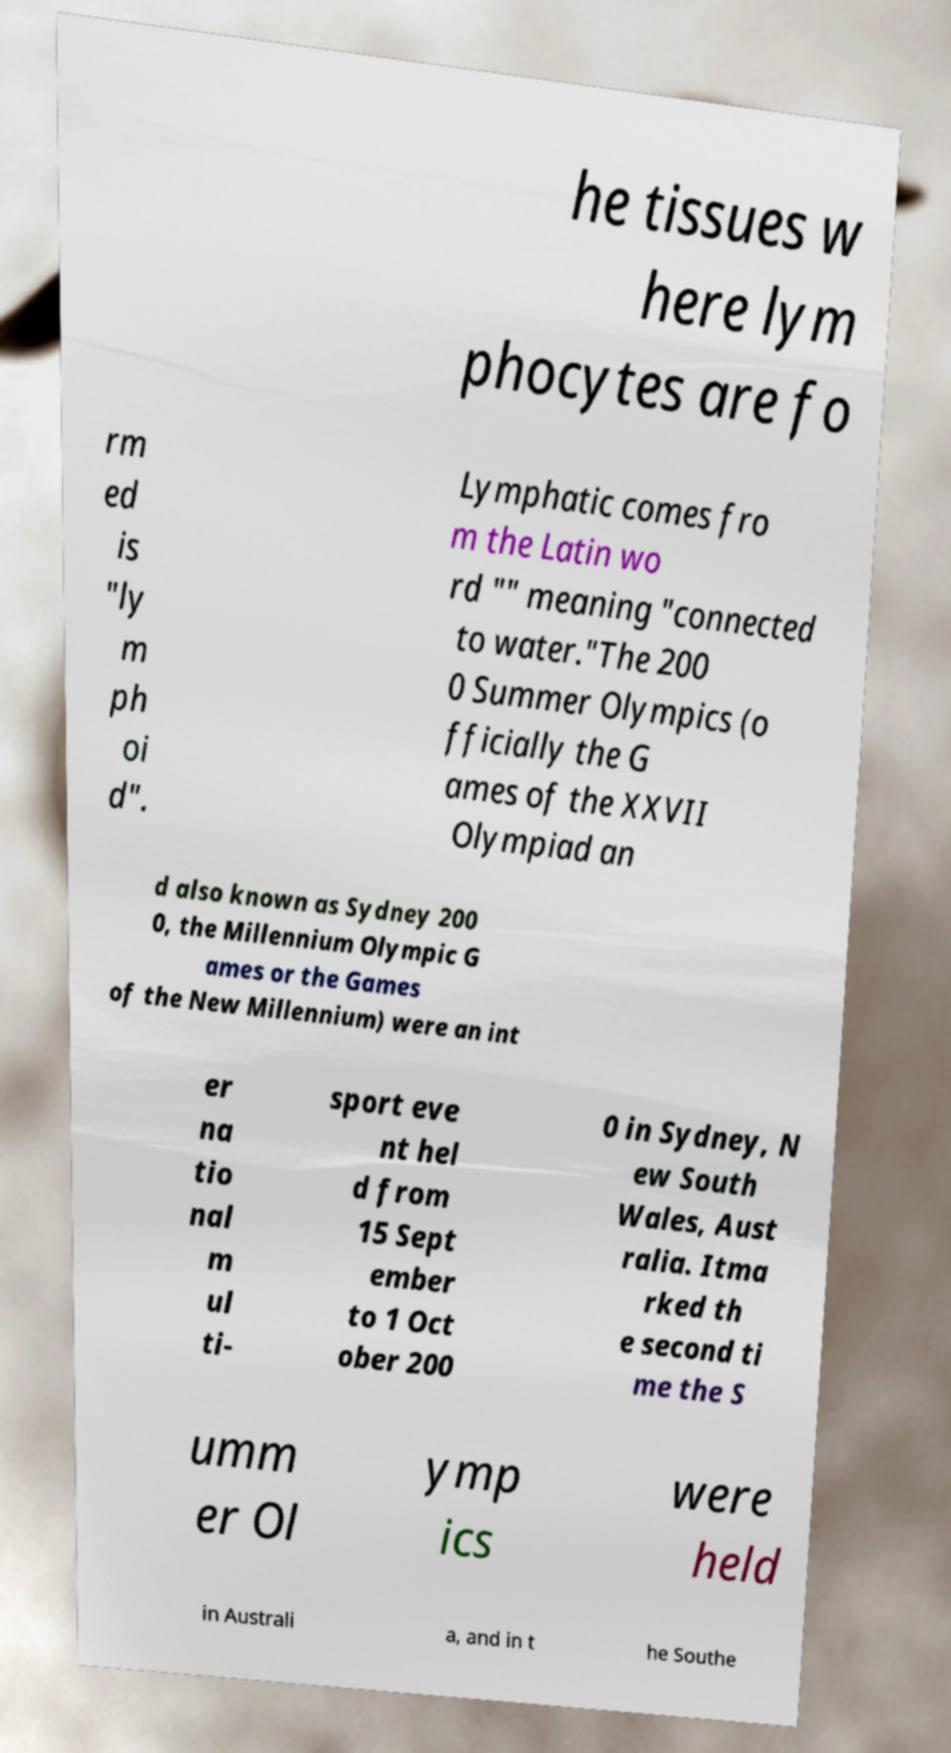Please identify and transcribe the text found in this image. he tissues w here lym phocytes are fo rm ed is "ly m ph oi d". Lymphatic comes fro m the Latin wo rd "" meaning "connected to water."The 200 0 Summer Olympics (o fficially the G ames of the XXVII Olympiad an d also known as Sydney 200 0, the Millennium Olympic G ames or the Games of the New Millennium) were an int er na tio nal m ul ti- sport eve nt hel d from 15 Sept ember to 1 Oct ober 200 0 in Sydney, N ew South Wales, Aust ralia. Itma rked th e second ti me the S umm er Ol ymp ics were held in Australi a, and in t he Southe 